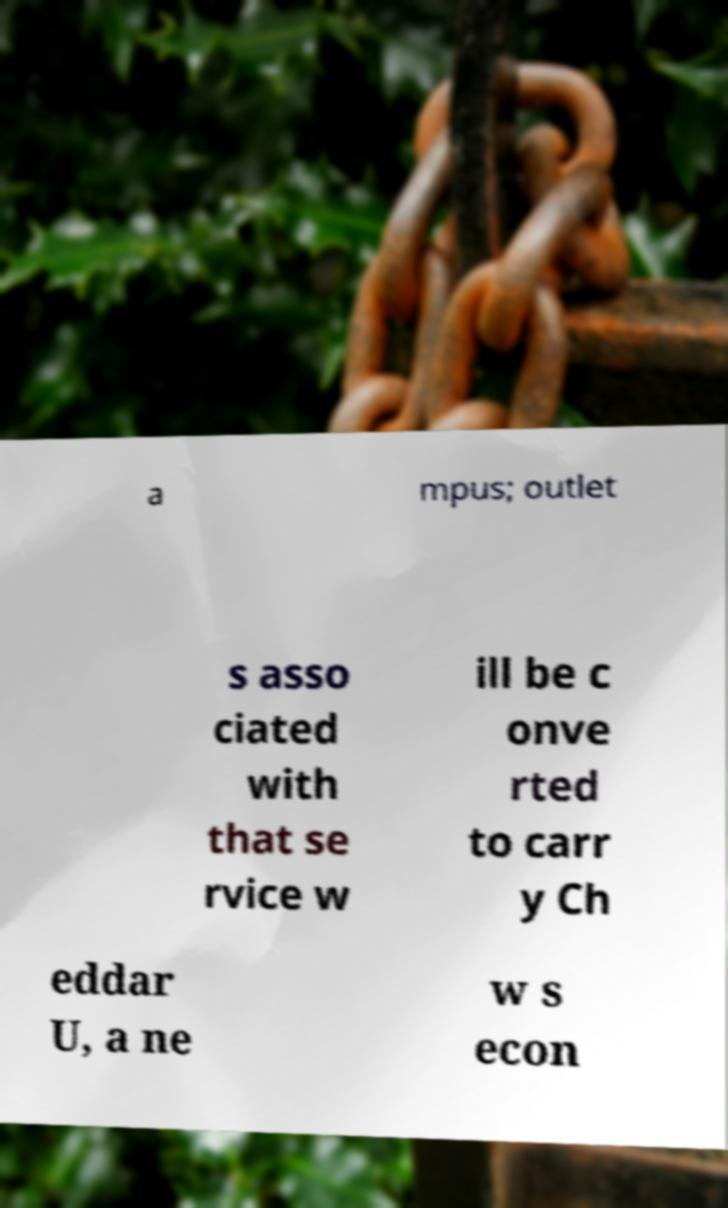Could you assist in decoding the text presented in this image and type it out clearly? a mpus; outlet s asso ciated with that se rvice w ill be c onve rted to carr y Ch eddar U, a ne w s econ 